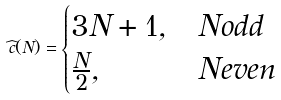Convert formula to latex. <formula><loc_0><loc_0><loc_500><loc_500>\widehat { c } ( N ) = \begin{cases} 3 N + 1 , & N o d d \\ \frac { N } { 2 } , & N e v e n \end{cases}</formula> 